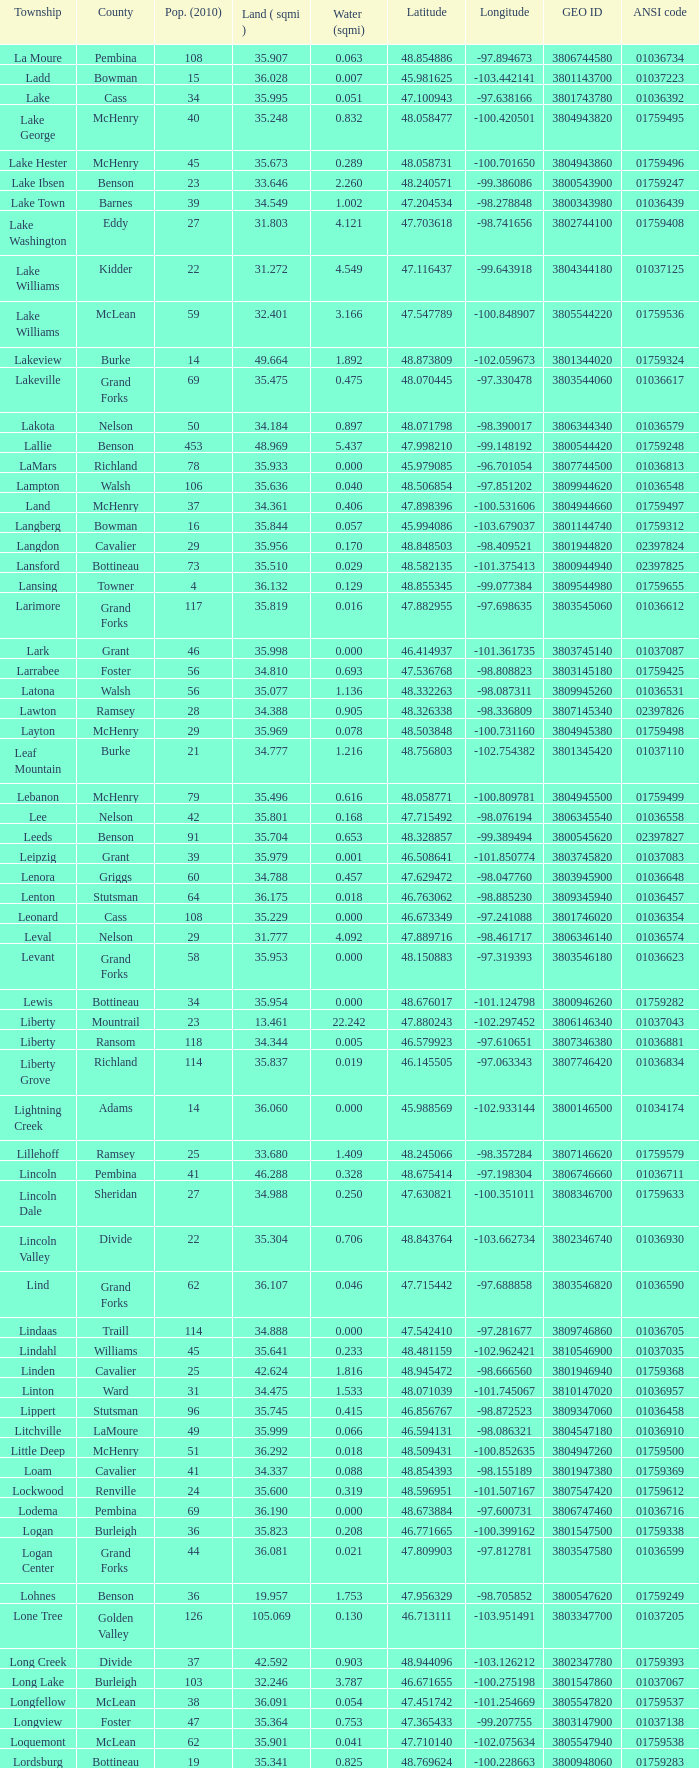What is the geographic latitude when the population from 2010 equals 24 and water quantity surpasses None. 